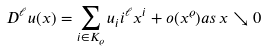Convert formula to latex. <formula><loc_0><loc_0><loc_500><loc_500>D ^ { \ell } u ( x ) = \sum _ { i \in K _ { \varrho } } u _ { i } i ^ { \ell } x ^ { i } + o ( x ^ { \varrho } ) a s \, x \searrow 0</formula> 